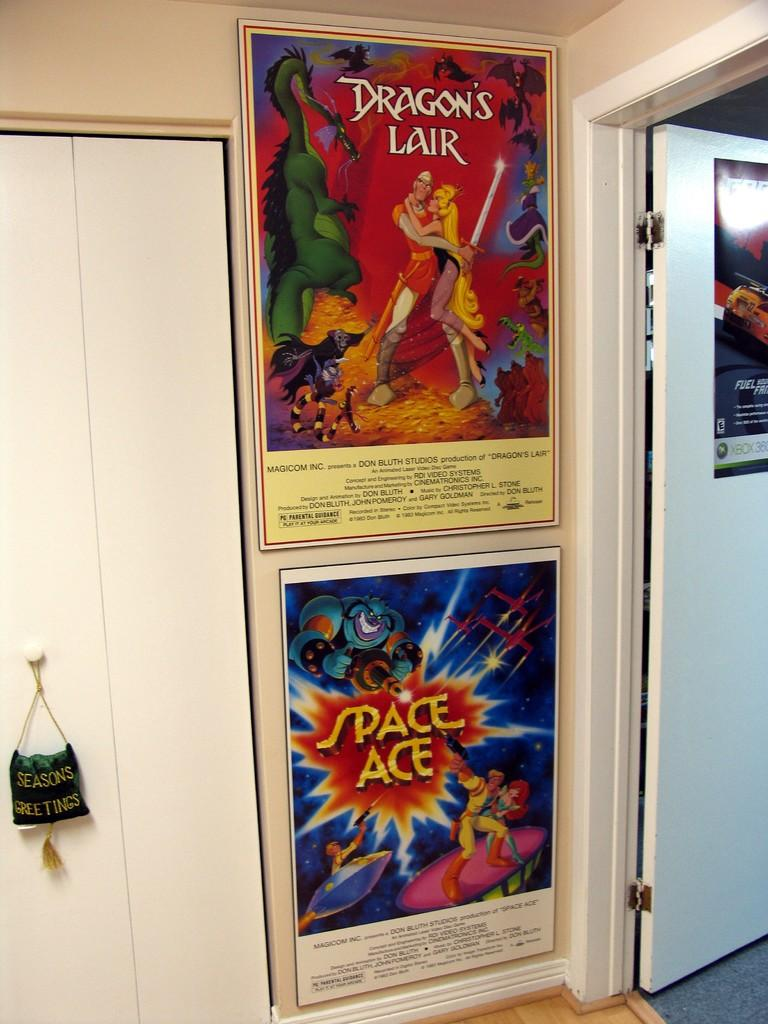<image>
Create a compact narrative representing the image presented. Two posters for Dragon's Lair and Space Ace hang on a white wall. 